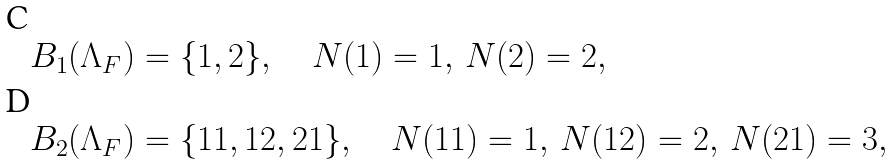Convert formula to latex. <formula><loc_0><loc_0><loc_500><loc_500>B _ { 1 } ( \Lambda _ { F } ) & = \{ 1 , 2 \} , \quad N ( 1 ) = 1 , \, N ( 2 ) = 2 , \\ B _ { 2 } ( \Lambda _ { F } ) & = \{ 1 1 , 1 2 , 2 1 \} , \quad N ( 1 1 ) = 1 , \, N ( 1 2 ) = 2 , \, N ( 2 1 ) = 3 ,</formula> 